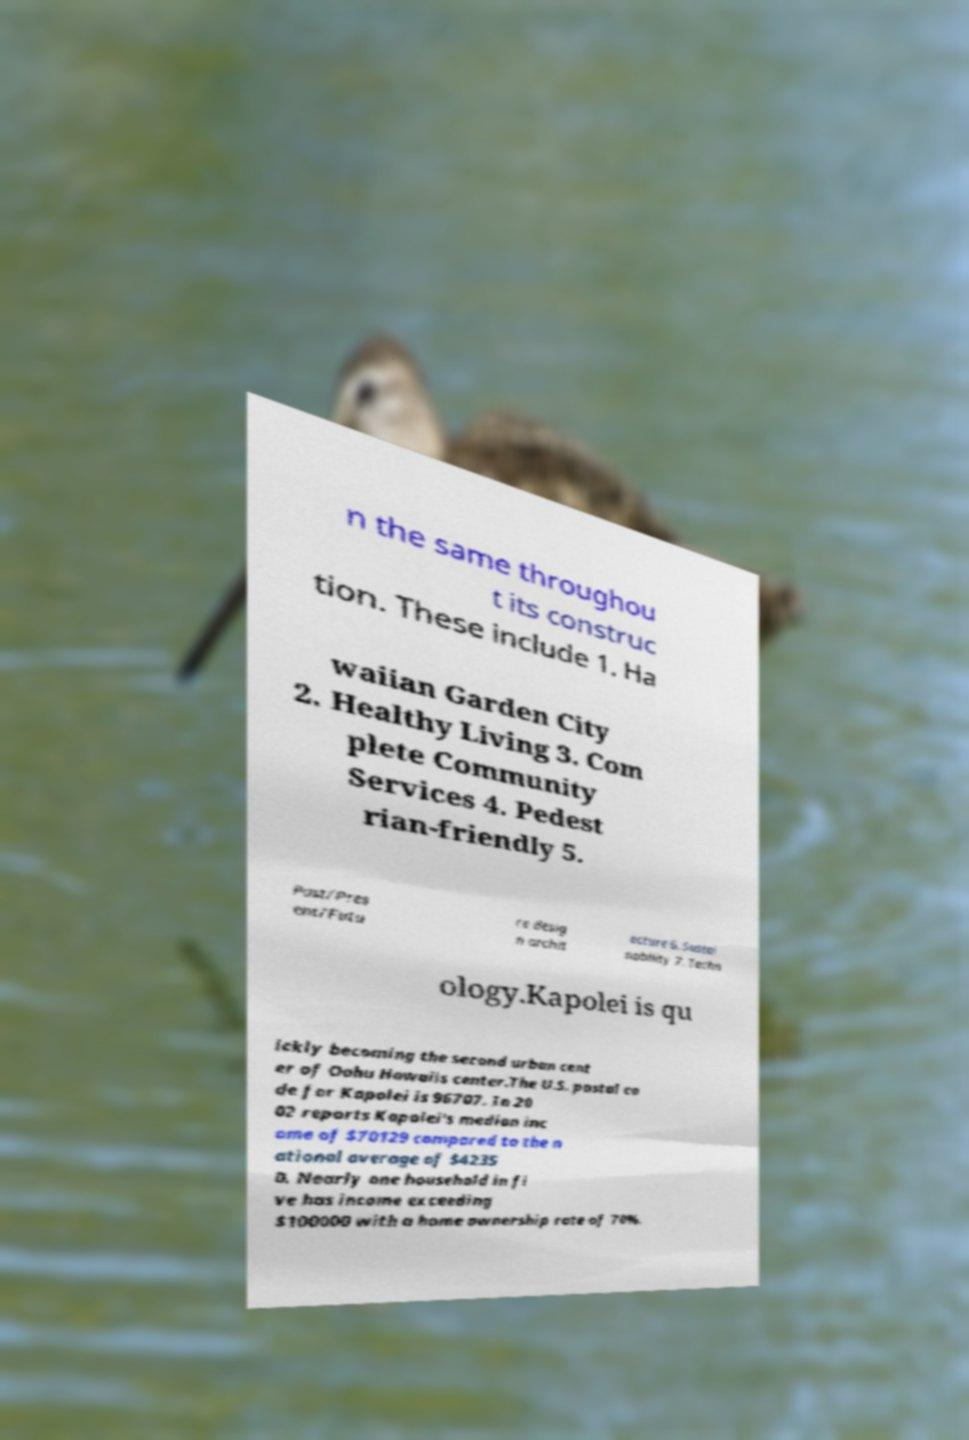Could you extract and type out the text from this image? n the same throughou t its construc tion. These include 1. Ha waiian Garden City 2. Healthy Living 3. Com plete Community Services 4. Pedest rian-friendly 5. Past/Pres ent/Futu re desig n archit ecture 6. Sustai nability 7. Techn ology.Kapolei is qu ickly becoming the second urban cent er of Oahu Hawaiis center.The U.S. postal co de for Kapolei is 96707. In 20 02 reports Kapolei's median inc ome of $70129 compared to the n ational average of $4235 0. Nearly one household in fi ve has income exceeding $100000 with a home ownership rate of 70%. 